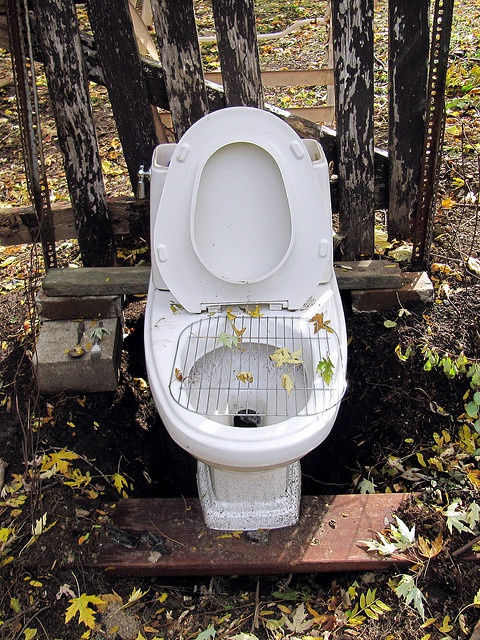Describe the objects in this image and their specific colors. I can see a toilet in black, lightgray, darkgray, and gray tones in this image. 